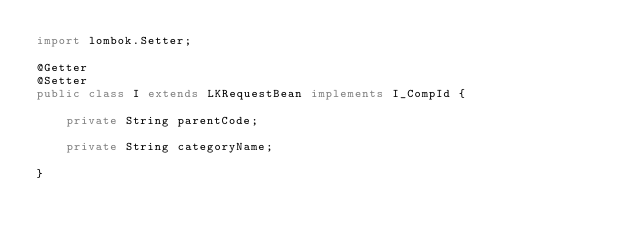Convert code to text. <code><loc_0><loc_0><loc_500><loc_500><_Java_>import lombok.Setter;

@Getter
@Setter
public class I extends LKRequestBean implements I_CompId {

	private String parentCode;

	private String categoryName;

}
</code> 